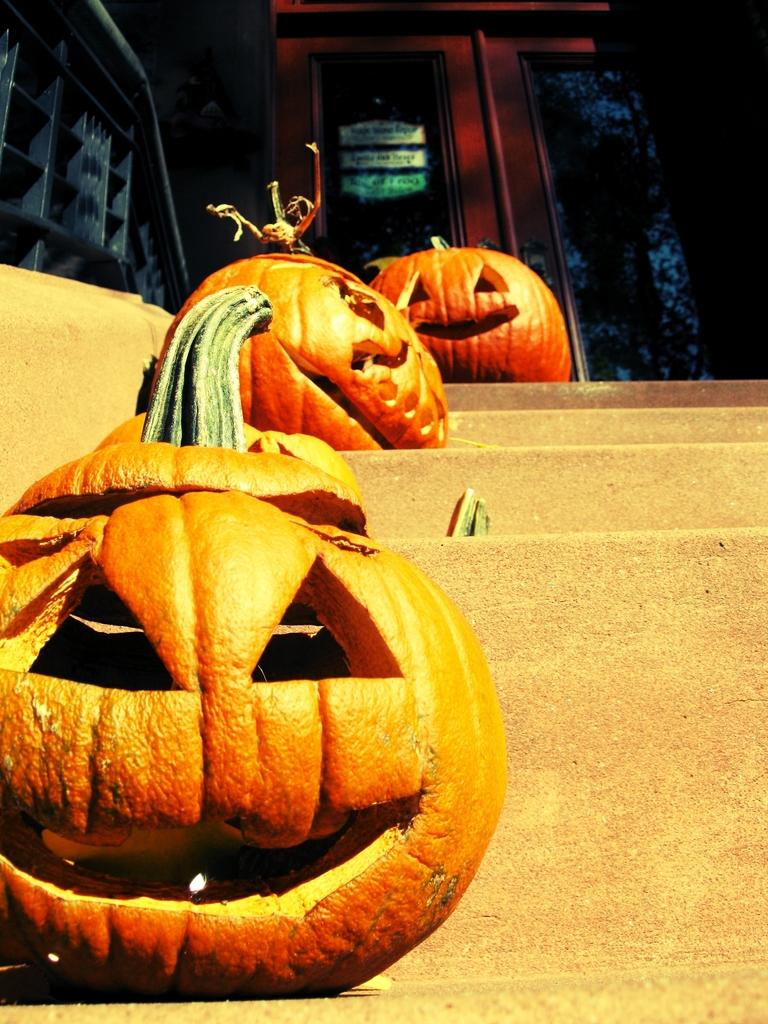What objects are present in the image? There are pumpkins in the image. Where are the pumpkins located? The pumpkins are placed on the stairs. What can be seen in the background of the image? There is a door in the backdrop of the image. How many girls are holding hands with the pumpkins in the image? There are no girls or hands present in the image; it only features pumpkins placed on the stairs and a door in the background. 